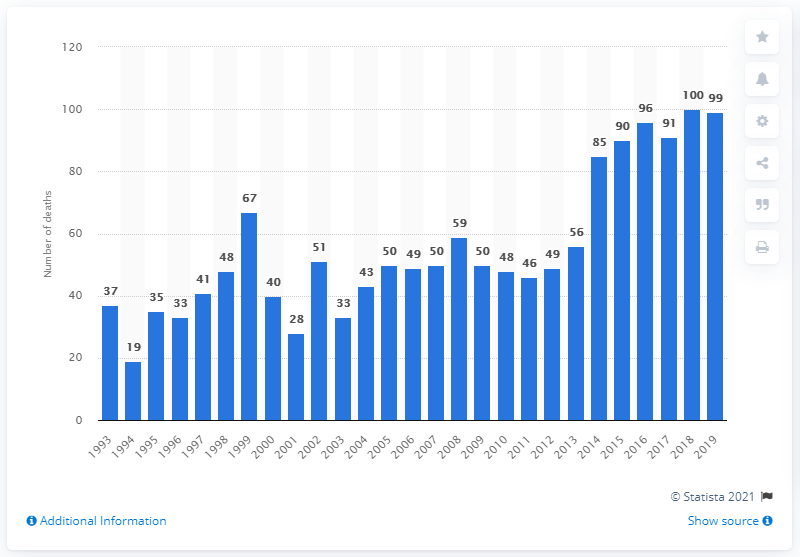Outline some significant characteristics in this image. In 2014, there were 85 reported deaths as a result of amphetamine use. In 2019, there were 99 deaths related to amphetamine use in England and Wales. 